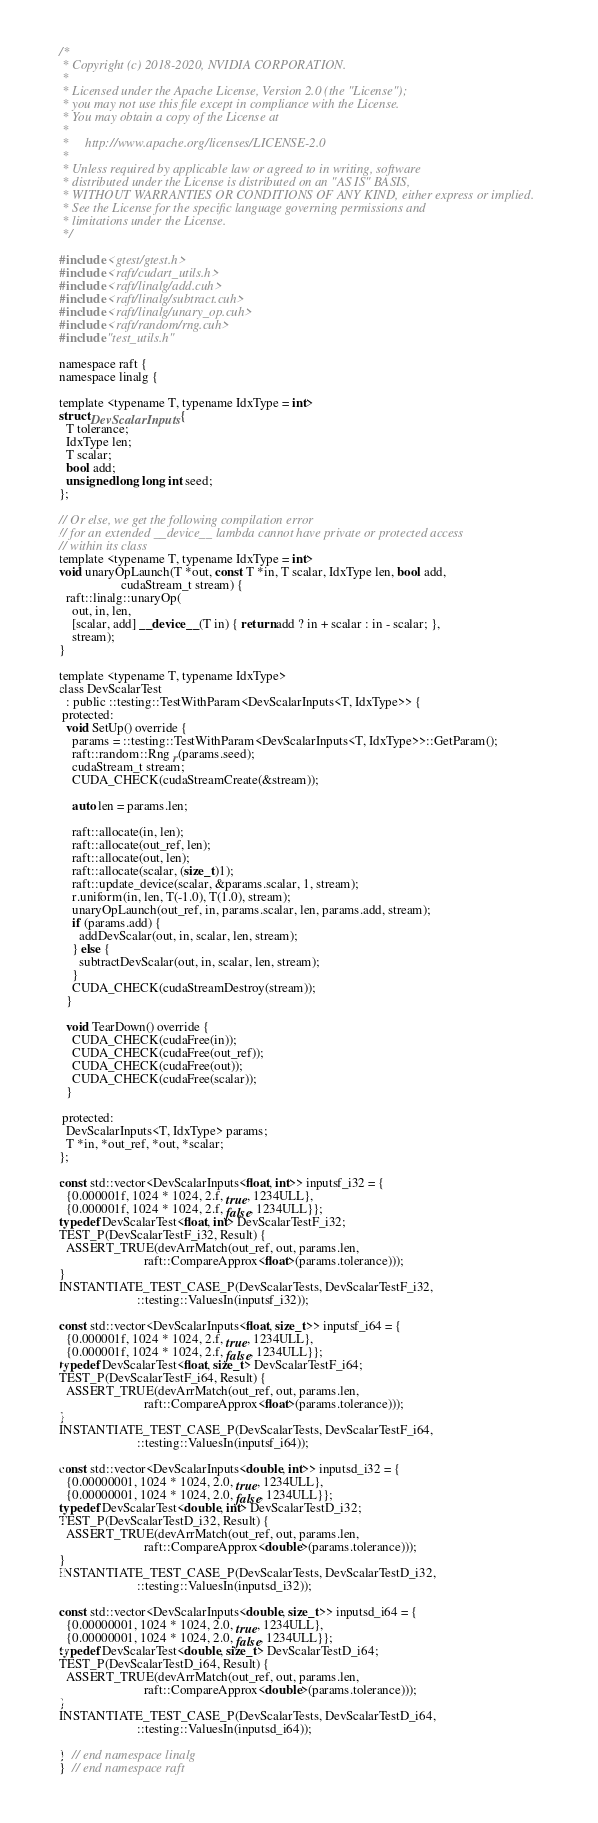<code> <loc_0><loc_0><loc_500><loc_500><_Cuda_>/*
 * Copyright (c) 2018-2020, NVIDIA CORPORATION.
 *
 * Licensed under the Apache License, Version 2.0 (the "License");
 * you may not use this file except in compliance with the License.
 * You may obtain a copy of the License at
 *
 *     http://www.apache.org/licenses/LICENSE-2.0
 *
 * Unless required by applicable law or agreed to in writing, software
 * distributed under the License is distributed on an "AS IS" BASIS,
 * WITHOUT WARRANTIES OR CONDITIONS OF ANY KIND, either express or implied.
 * See the License for the specific language governing permissions and
 * limitations under the License.
 */

#include <gtest/gtest.h>
#include <raft/cudart_utils.h>
#include <raft/linalg/add.cuh>
#include <raft/linalg/subtract.cuh>
#include <raft/linalg/unary_op.cuh>
#include <raft/random/rng.cuh>
#include "test_utils.h"

namespace raft {
namespace linalg {

template <typename T, typename IdxType = int>
struct DevScalarInputs {
  T tolerance;
  IdxType len;
  T scalar;
  bool add;
  unsigned long long int seed;
};

// Or else, we get the following compilation error
// for an extended __device__ lambda cannot have private or protected access
// within its class
template <typename T, typename IdxType = int>
void unaryOpLaunch(T *out, const T *in, T scalar, IdxType len, bool add,
                   cudaStream_t stream) {
  raft::linalg::unaryOp(
    out, in, len,
    [scalar, add] __device__(T in) { return add ? in + scalar : in - scalar; },
    stream);
}

template <typename T, typename IdxType>
class DevScalarTest
  : public ::testing::TestWithParam<DevScalarInputs<T, IdxType>> {
 protected:
  void SetUp() override {
    params = ::testing::TestWithParam<DevScalarInputs<T, IdxType>>::GetParam();
    raft::random::Rng r(params.seed);
    cudaStream_t stream;
    CUDA_CHECK(cudaStreamCreate(&stream));

    auto len = params.len;

    raft::allocate(in, len);
    raft::allocate(out_ref, len);
    raft::allocate(out, len);
    raft::allocate(scalar, (size_t)1);
    raft::update_device(scalar, &params.scalar, 1, stream);
    r.uniform(in, len, T(-1.0), T(1.0), stream);
    unaryOpLaunch(out_ref, in, params.scalar, len, params.add, stream);
    if (params.add) {
      addDevScalar(out, in, scalar, len, stream);
    } else {
      subtractDevScalar(out, in, scalar, len, stream);
    }
    CUDA_CHECK(cudaStreamDestroy(stream));
  }

  void TearDown() override {
    CUDA_CHECK(cudaFree(in));
    CUDA_CHECK(cudaFree(out_ref));
    CUDA_CHECK(cudaFree(out));
    CUDA_CHECK(cudaFree(scalar));
  }

 protected:
  DevScalarInputs<T, IdxType> params;
  T *in, *out_ref, *out, *scalar;
};

const std::vector<DevScalarInputs<float, int>> inputsf_i32 = {
  {0.000001f, 1024 * 1024, 2.f, true, 1234ULL},
  {0.000001f, 1024 * 1024, 2.f, false, 1234ULL}};
typedef DevScalarTest<float, int> DevScalarTestF_i32;
TEST_P(DevScalarTestF_i32, Result) {
  ASSERT_TRUE(devArrMatch(out_ref, out, params.len,
                          raft::CompareApprox<float>(params.tolerance)));
}
INSTANTIATE_TEST_CASE_P(DevScalarTests, DevScalarTestF_i32,
                        ::testing::ValuesIn(inputsf_i32));

const std::vector<DevScalarInputs<float, size_t>> inputsf_i64 = {
  {0.000001f, 1024 * 1024, 2.f, true, 1234ULL},
  {0.000001f, 1024 * 1024, 2.f, false, 1234ULL}};
typedef DevScalarTest<float, size_t> DevScalarTestF_i64;
TEST_P(DevScalarTestF_i64, Result) {
  ASSERT_TRUE(devArrMatch(out_ref, out, params.len,
                          raft::CompareApprox<float>(params.tolerance)));
}
INSTANTIATE_TEST_CASE_P(DevScalarTests, DevScalarTestF_i64,
                        ::testing::ValuesIn(inputsf_i64));

const std::vector<DevScalarInputs<double, int>> inputsd_i32 = {
  {0.00000001, 1024 * 1024, 2.0, true, 1234ULL},
  {0.00000001, 1024 * 1024, 2.0, false, 1234ULL}};
typedef DevScalarTest<double, int> DevScalarTestD_i32;
TEST_P(DevScalarTestD_i32, Result) {
  ASSERT_TRUE(devArrMatch(out_ref, out, params.len,
                          raft::CompareApprox<double>(params.tolerance)));
}
INSTANTIATE_TEST_CASE_P(DevScalarTests, DevScalarTestD_i32,
                        ::testing::ValuesIn(inputsd_i32));

const std::vector<DevScalarInputs<double, size_t>> inputsd_i64 = {
  {0.00000001, 1024 * 1024, 2.0, true, 1234ULL},
  {0.00000001, 1024 * 1024, 2.0, false, 1234ULL}};
typedef DevScalarTest<double, size_t> DevScalarTestD_i64;
TEST_P(DevScalarTestD_i64, Result) {
  ASSERT_TRUE(devArrMatch(out_ref, out, params.len,
                          raft::CompareApprox<double>(params.tolerance)));
}
INSTANTIATE_TEST_CASE_P(DevScalarTests, DevScalarTestD_i64,
                        ::testing::ValuesIn(inputsd_i64));

}  // end namespace linalg
}  // end namespace raft
</code> 